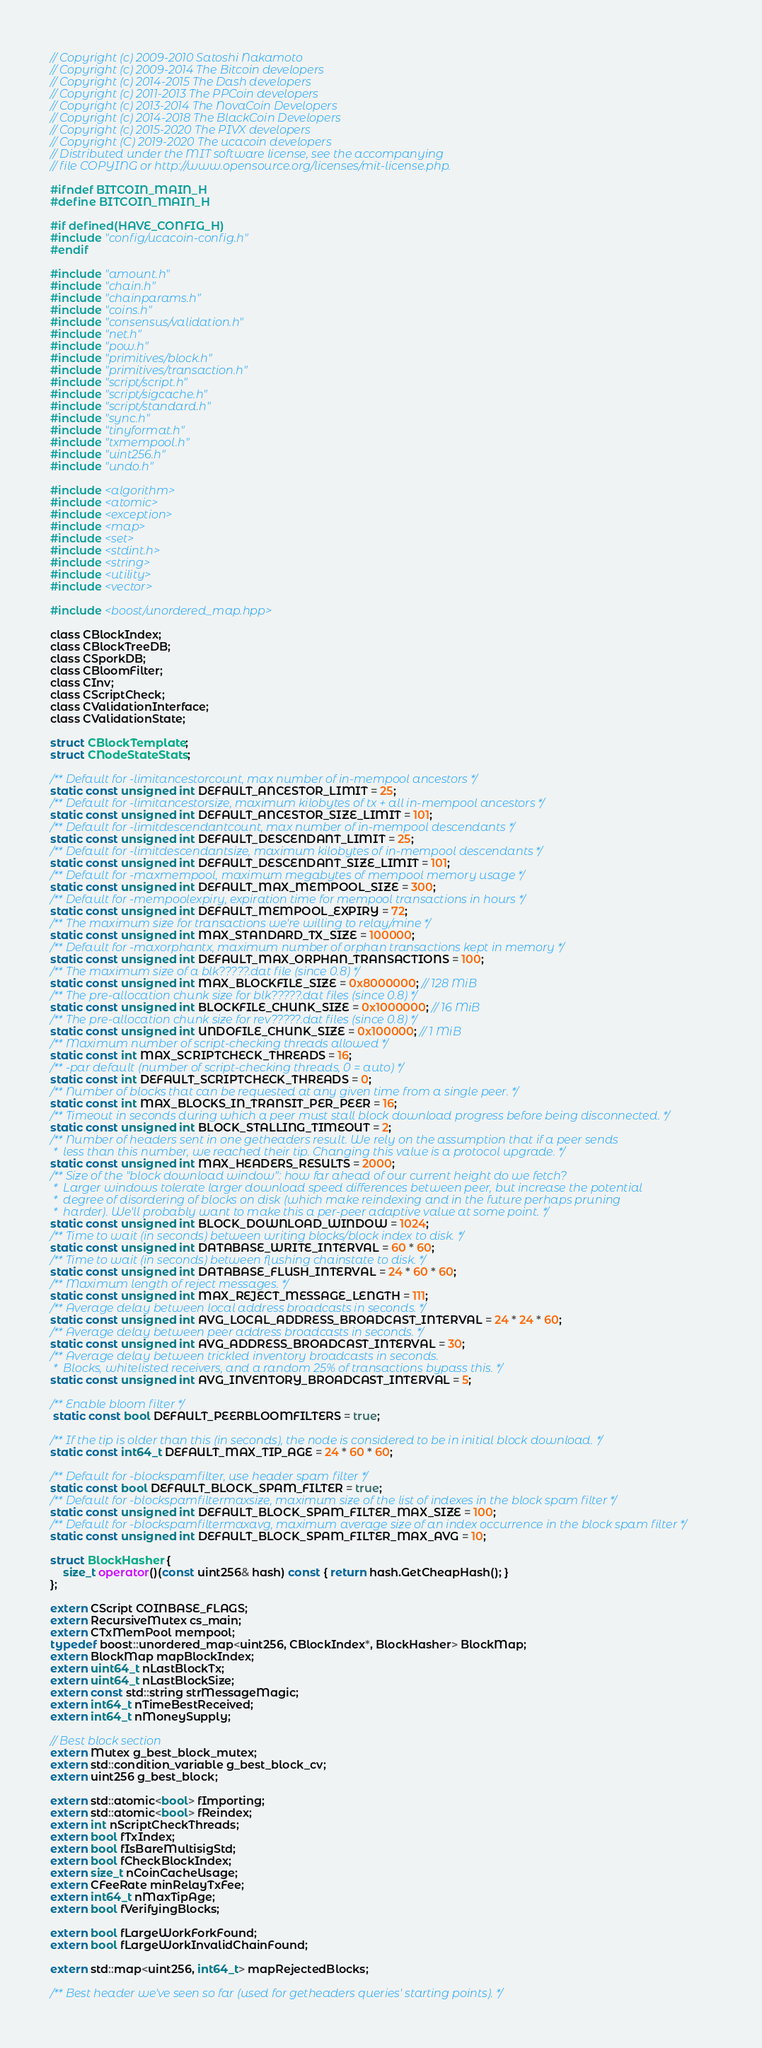Convert code to text. <code><loc_0><loc_0><loc_500><loc_500><_C_>// Copyright (c) 2009-2010 Satoshi Nakamoto
// Copyright (c) 2009-2014 The Bitcoin developers
// Copyright (c) 2014-2015 The Dash developers
// Copyright (c) 2011-2013 The PPCoin developers
// Copyright (c) 2013-2014 The NovaCoin Developers
// Copyright (c) 2014-2018 The BlackCoin Developers
// Copyright (c) 2015-2020 The PIVX developers
// Copyright (C) 2019-2020 The ucacoin developers
// Distributed under the MIT software license, see the accompanying
// file COPYING or http://www.opensource.org/licenses/mit-license.php.

#ifndef BITCOIN_MAIN_H
#define BITCOIN_MAIN_H

#if defined(HAVE_CONFIG_H)
#include "config/ucacoin-config.h"
#endif

#include "amount.h"
#include "chain.h"
#include "chainparams.h"
#include "coins.h"
#include "consensus/validation.h"
#include "net.h"
#include "pow.h"
#include "primitives/block.h"
#include "primitives/transaction.h"
#include "script/script.h"
#include "script/sigcache.h"
#include "script/standard.h"
#include "sync.h"
#include "tinyformat.h"
#include "txmempool.h"
#include "uint256.h"
#include "undo.h"

#include <algorithm>
#include <atomic>
#include <exception>
#include <map>
#include <set>
#include <stdint.h>
#include <string>
#include <utility>
#include <vector>

#include <boost/unordered_map.hpp>

class CBlockIndex;
class CBlockTreeDB;
class CSporkDB;
class CBloomFilter;
class CInv;
class CScriptCheck;
class CValidationInterface;
class CValidationState;

struct CBlockTemplate;
struct CNodeStateStats;

/** Default for -limitancestorcount, max number of in-mempool ancestors */
static const unsigned int DEFAULT_ANCESTOR_LIMIT = 25;
/** Default for -limitancestorsize, maximum kilobytes of tx + all in-mempool ancestors */
static const unsigned int DEFAULT_ANCESTOR_SIZE_LIMIT = 101;
/** Default for -limitdescendantcount, max number of in-mempool descendants */
static const unsigned int DEFAULT_DESCENDANT_LIMIT = 25;
/** Default for -limitdescendantsize, maximum kilobytes of in-mempool descendants */
static const unsigned int DEFAULT_DESCENDANT_SIZE_LIMIT = 101;
/** Default for -maxmempool, maximum megabytes of mempool memory usage */
static const unsigned int DEFAULT_MAX_MEMPOOL_SIZE = 300;
/** Default for -mempoolexpiry, expiration time for mempool transactions in hours */
static const unsigned int DEFAULT_MEMPOOL_EXPIRY = 72;
/** The maximum size for transactions we're willing to relay/mine */
static const unsigned int MAX_STANDARD_TX_SIZE = 100000;
/** Default for -maxorphantx, maximum number of orphan transactions kept in memory */
static const unsigned int DEFAULT_MAX_ORPHAN_TRANSACTIONS = 100;
/** The maximum size of a blk?????.dat file (since 0.8) */
static const unsigned int MAX_BLOCKFILE_SIZE = 0x8000000; // 128 MiB
/** The pre-allocation chunk size for blk?????.dat files (since 0.8) */
static const unsigned int BLOCKFILE_CHUNK_SIZE = 0x1000000; // 16 MiB
/** The pre-allocation chunk size for rev?????.dat files (since 0.8) */
static const unsigned int UNDOFILE_CHUNK_SIZE = 0x100000; // 1 MiB
/** Maximum number of script-checking threads allowed */
static const int MAX_SCRIPTCHECK_THREADS = 16;
/** -par default (number of script-checking threads, 0 = auto) */
static const int DEFAULT_SCRIPTCHECK_THREADS = 0;
/** Number of blocks that can be requested at any given time from a single peer. */
static const int MAX_BLOCKS_IN_TRANSIT_PER_PEER = 16;
/** Timeout in seconds during which a peer must stall block download progress before being disconnected. */
static const unsigned int BLOCK_STALLING_TIMEOUT = 2;
/** Number of headers sent in one getheaders result. We rely on the assumption that if a peer sends
 *  less than this number, we reached their tip. Changing this value is a protocol upgrade. */
static const unsigned int MAX_HEADERS_RESULTS = 2000;
/** Size of the "block download window": how far ahead of our current height do we fetch?
 *  Larger windows tolerate larger download speed differences between peer, but increase the potential
 *  degree of disordering of blocks on disk (which make reindexing and in the future perhaps pruning
 *  harder). We'll probably want to make this a per-peer adaptive value at some point. */
static const unsigned int BLOCK_DOWNLOAD_WINDOW = 1024;
/** Time to wait (in seconds) between writing blocks/block index to disk. */
static const unsigned int DATABASE_WRITE_INTERVAL = 60 * 60;
/** Time to wait (in seconds) between flushing chainstate to disk. */
static const unsigned int DATABASE_FLUSH_INTERVAL = 24 * 60 * 60;
/** Maximum length of reject messages. */
static const unsigned int MAX_REJECT_MESSAGE_LENGTH = 111;
/** Average delay between local address broadcasts in seconds. */
static const unsigned int AVG_LOCAL_ADDRESS_BROADCAST_INTERVAL = 24 * 24 * 60;
/** Average delay between peer address broadcasts in seconds. */
static const unsigned int AVG_ADDRESS_BROADCAST_INTERVAL = 30;
/** Average delay between trickled inventory broadcasts in seconds.
 *  Blocks, whitelisted receivers, and a random 25% of transactions bypass this. */
static const unsigned int AVG_INVENTORY_BROADCAST_INTERVAL = 5;

/** Enable bloom filter */
 static const bool DEFAULT_PEERBLOOMFILTERS = true;

/** If the tip is older than this (in seconds), the node is considered to be in initial block download. */
static const int64_t DEFAULT_MAX_TIP_AGE = 24 * 60 * 60;

/** Default for -blockspamfilter, use header spam filter */
static const bool DEFAULT_BLOCK_SPAM_FILTER = true;
/** Default for -blockspamfiltermaxsize, maximum size of the list of indexes in the block spam filter */
static const unsigned int DEFAULT_BLOCK_SPAM_FILTER_MAX_SIZE = 100;
/** Default for -blockspamfiltermaxavg, maximum average size of an index occurrence in the block spam filter */
static const unsigned int DEFAULT_BLOCK_SPAM_FILTER_MAX_AVG = 10;

struct BlockHasher {
    size_t operator()(const uint256& hash) const { return hash.GetCheapHash(); }
};

extern CScript COINBASE_FLAGS;
extern RecursiveMutex cs_main;
extern CTxMemPool mempool;
typedef boost::unordered_map<uint256, CBlockIndex*, BlockHasher> BlockMap;
extern BlockMap mapBlockIndex;
extern uint64_t nLastBlockTx;
extern uint64_t nLastBlockSize;
extern const std::string strMessageMagic;
extern int64_t nTimeBestReceived;
extern int64_t nMoneySupply;

// Best block section
extern Mutex g_best_block_mutex;
extern std::condition_variable g_best_block_cv;
extern uint256 g_best_block;

extern std::atomic<bool> fImporting;
extern std::atomic<bool> fReindex;
extern int nScriptCheckThreads;
extern bool fTxIndex;
extern bool fIsBareMultisigStd;
extern bool fCheckBlockIndex;
extern size_t nCoinCacheUsage;
extern CFeeRate minRelayTxFee;
extern int64_t nMaxTipAge;
extern bool fVerifyingBlocks;

extern bool fLargeWorkForkFound;
extern bool fLargeWorkInvalidChainFound;

extern std::map<uint256, int64_t> mapRejectedBlocks;

/** Best header we've seen so far (used for getheaders queries' starting points). */</code> 